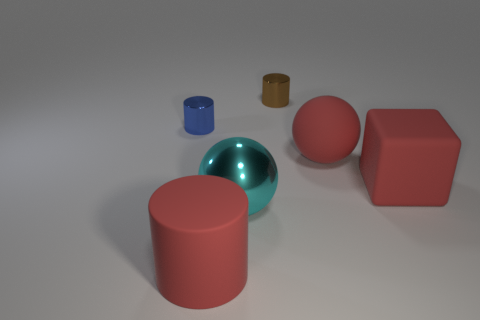Subtract 1 cylinders. How many cylinders are left? 2 Add 1 big yellow objects. How many objects exist? 7 Subtract all spheres. How many objects are left? 4 Subtract all large red metallic blocks. Subtract all brown metallic cylinders. How many objects are left? 5 Add 1 matte blocks. How many matte blocks are left? 2 Add 4 small blue things. How many small blue things exist? 5 Subtract 1 red spheres. How many objects are left? 5 